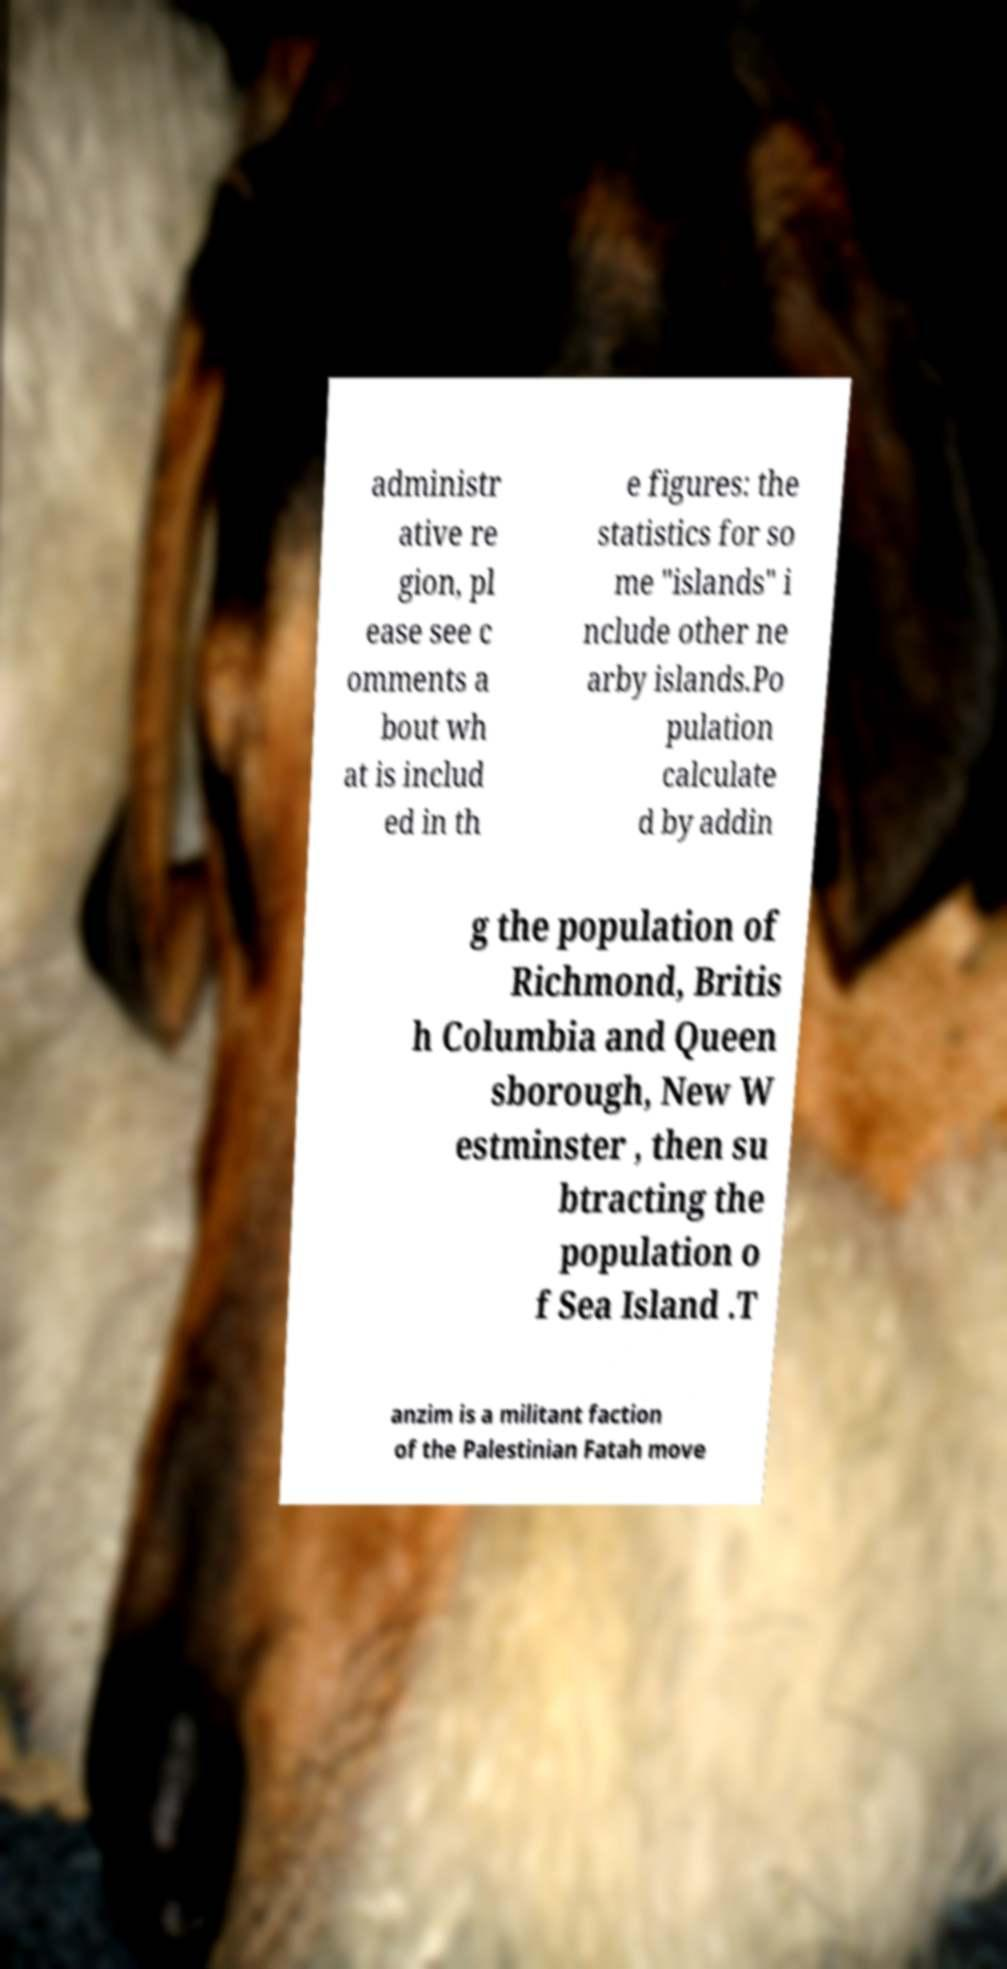Can you read and provide the text displayed in the image?This photo seems to have some interesting text. Can you extract and type it out for me? administr ative re gion, pl ease see c omments a bout wh at is includ ed in th e figures: the statistics for so me "islands" i nclude other ne arby islands.Po pulation calculate d by addin g the population of Richmond, Britis h Columbia and Queen sborough, New W estminster , then su btracting the population o f Sea Island .T anzim is a militant faction of the Palestinian Fatah move 